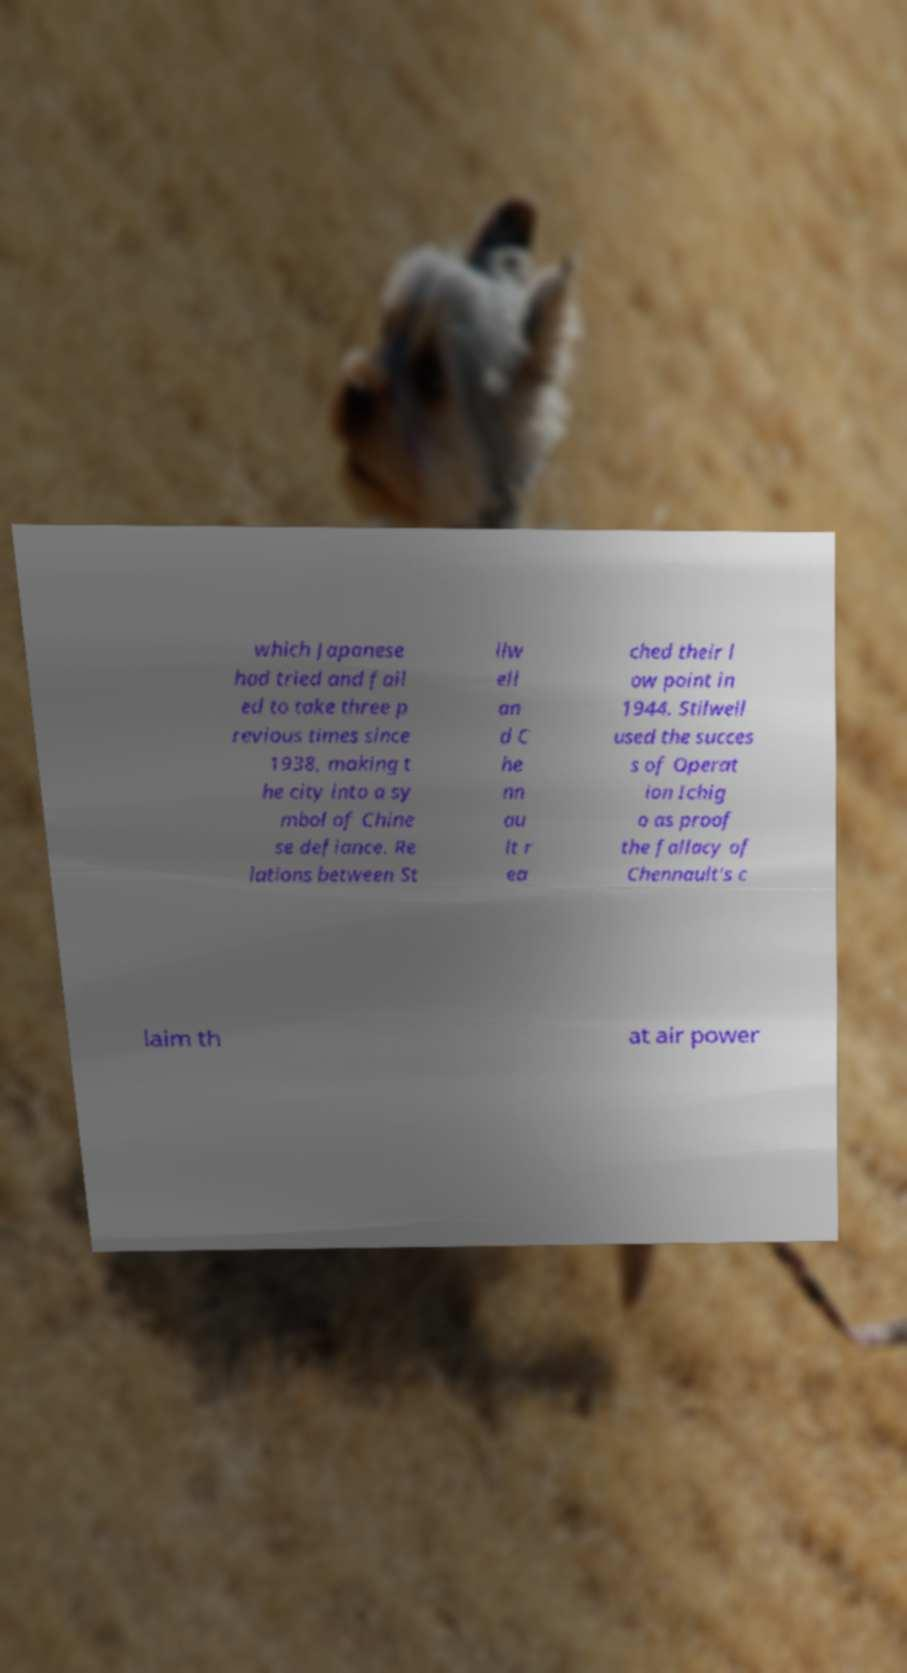Could you extract and type out the text from this image? which Japanese had tried and fail ed to take three p revious times since 1938, making t he city into a sy mbol of Chine se defiance. Re lations between St ilw ell an d C he nn au lt r ea ched their l ow point in 1944. Stilwell used the succes s of Operat ion Ichig o as proof the fallacy of Chennault's c laim th at air power 